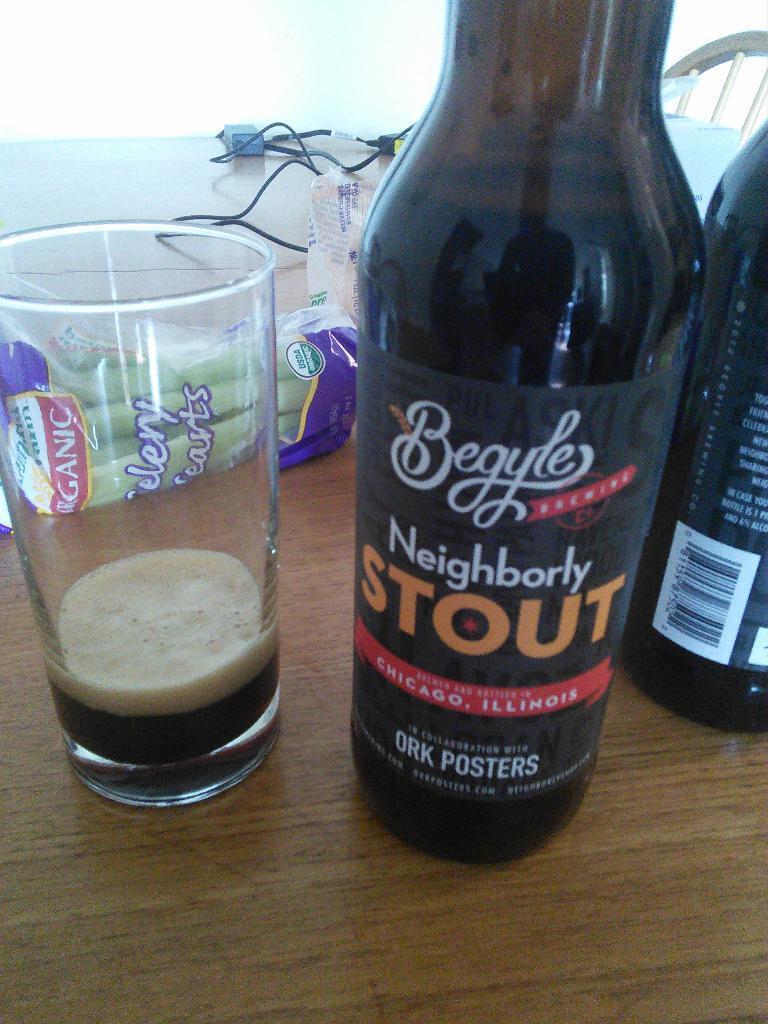Can you describe this image briefly? In this image I can see on the left side there is a wine glass with a sticker on it. 